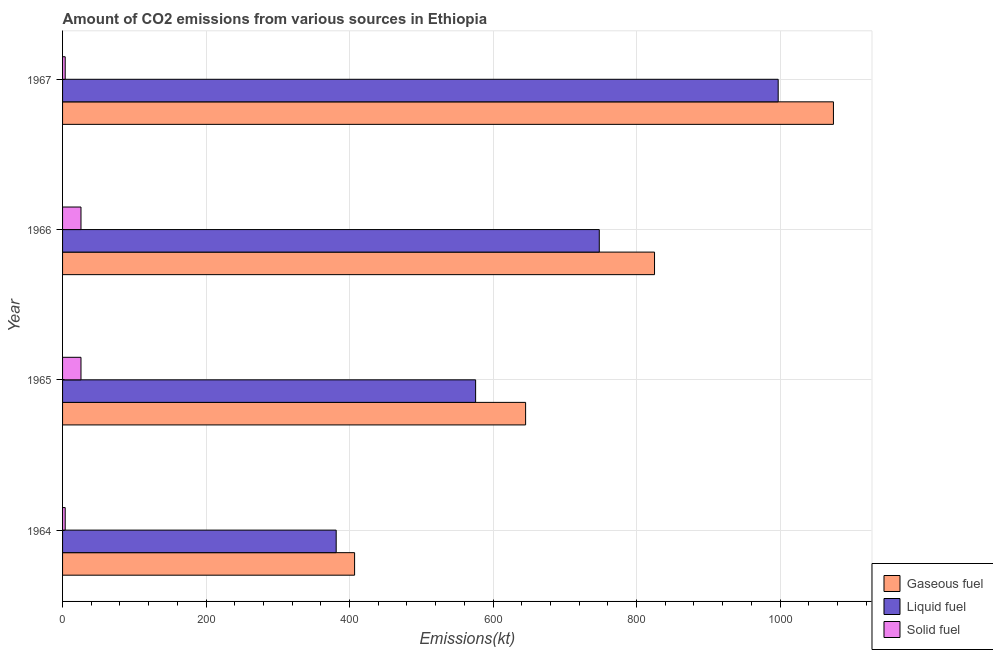How many bars are there on the 4th tick from the bottom?
Give a very brief answer. 3. What is the label of the 3rd group of bars from the top?
Your response must be concise. 1965. In how many cases, is the number of bars for a given year not equal to the number of legend labels?
Your response must be concise. 0. What is the amount of co2 emissions from solid fuel in 1964?
Provide a succinct answer. 3.67. Across all years, what is the maximum amount of co2 emissions from liquid fuel?
Offer a very short reply. 997.42. Across all years, what is the minimum amount of co2 emissions from liquid fuel?
Provide a succinct answer. 381.37. In which year was the amount of co2 emissions from gaseous fuel maximum?
Your response must be concise. 1967. In which year was the amount of co2 emissions from liquid fuel minimum?
Ensure brevity in your answer.  1964. What is the total amount of co2 emissions from gaseous fuel in the graph?
Offer a terse response. 2951.93. What is the difference between the amount of co2 emissions from solid fuel in 1964 and that in 1966?
Your response must be concise. -22. What is the difference between the amount of co2 emissions from liquid fuel in 1966 and the amount of co2 emissions from gaseous fuel in 1965?
Your response must be concise. 102.68. What is the average amount of co2 emissions from liquid fuel per year?
Provide a short and direct response. 675.64. In the year 1967, what is the difference between the amount of co2 emissions from liquid fuel and amount of co2 emissions from solid fuel?
Your answer should be very brief. 993.76. What is the ratio of the amount of co2 emissions from gaseous fuel in 1964 to that in 1967?
Offer a terse response. 0.38. Is the amount of co2 emissions from gaseous fuel in 1965 less than that in 1966?
Offer a terse response. Yes. Is the difference between the amount of co2 emissions from gaseous fuel in 1965 and 1967 greater than the difference between the amount of co2 emissions from solid fuel in 1965 and 1967?
Your answer should be compact. No. What is the difference between the highest and the second highest amount of co2 emissions from gaseous fuel?
Provide a short and direct response. 249.36. What is the difference between the highest and the lowest amount of co2 emissions from liquid fuel?
Offer a terse response. 616.06. In how many years, is the amount of co2 emissions from liquid fuel greater than the average amount of co2 emissions from liquid fuel taken over all years?
Provide a succinct answer. 2. Is the sum of the amount of co2 emissions from solid fuel in 1964 and 1967 greater than the maximum amount of co2 emissions from liquid fuel across all years?
Offer a terse response. No. What does the 1st bar from the top in 1967 represents?
Your answer should be very brief. Solid fuel. What does the 1st bar from the bottom in 1967 represents?
Make the answer very short. Gaseous fuel. How many bars are there?
Provide a succinct answer. 12. How many years are there in the graph?
Provide a short and direct response. 4. Are the values on the major ticks of X-axis written in scientific E-notation?
Provide a succinct answer. No. Does the graph contain any zero values?
Offer a very short reply. No. Where does the legend appear in the graph?
Make the answer very short. Bottom right. How are the legend labels stacked?
Your response must be concise. Vertical. What is the title of the graph?
Keep it short and to the point. Amount of CO2 emissions from various sources in Ethiopia. Does "Injury" appear as one of the legend labels in the graph?
Offer a terse response. No. What is the label or title of the X-axis?
Keep it short and to the point. Emissions(kt). What is the label or title of the Y-axis?
Make the answer very short. Year. What is the Emissions(kt) in Gaseous fuel in 1964?
Give a very brief answer. 407.04. What is the Emissions(kt) in Liquid fuel in 1964?
Offer a terse response. 381.37. What is the Emissions(kt) in Solid fuel in 1964?
Offer a very short reply. 3.67. What is the Emissions(kt) of Gaseous fuel in 1965?
Your response must be concise. 645.39. What is the Emissions(kt) of Liquid fuel in 1965?
Make the answer very short. 575.72. What is the Emissions(kt) in Solid fuel in 1965?
Your answer should be very brief. 25.67. What is the Emissions(kt) of Gaseous fuel in 1966?
Provide a succinct answer. 825.08. What is the Emissions(kt) in Liquid fuel in 1966?
Your answer should be very brief. 748.07. What is the Emissions(kt) in Solid fuel in 1966?
Keep it short and to the point. 25.67. What is the Emissions(kt) of Gaseous fuel in 1967?
Your answer should be very brief. 1074.43. What is the Emissions(kt) in Liquid fuel in 1967?
Provide a short and direct response. 997.42. What is the Emissions(kt) of Solid fuel in 1967?
Your response must be concise. 3.67. Across all years, what is the maximum Emissions(kt) of Gaseous fuel?
Offer a very short reply. 1074.43. Across all years, what is the maximum Emissions(kt) in Liquid fuel?
Your response must be concise. 997.42. Across all years, what is the maximum Emissions(kt) of Solid fuel?
Provide a succinct answer. 25.67. Across all years, what is the minimum Emissions(kt) in Gaseous fuel?
Give a very brief answer. 407.04. Across all years, what is the minimum Emissions(kt) of Liquid fuel?
Keep it short and to the point. 381.37. Across all years, what is the minimum Emissions(kt) of Solid fuel?
Keep it short and to the point. 3.67. What is the total Emissions(kt) of Gaseous fuel in the graph?
Ensure brevity in your answer.  2951.93. What is the total Emissions(kt) of Liquid fuel in the graph?
Give a very brief answer. 2702.58. What is the total Emissions(kt) of Solid fuel in the graph?
Your answer should be very brief. 58.67. What is the difference between the Emissions(kt) in Gaseous fuel in 1964 and that in 1965?
Give a very brief answer. -238.35. What is the difference between the Emissions(kt) of Liquid fuel in 1964 and that in 1965?
Keep it short and to the point. -194.35. What is the difference between the Emissions(kt) in Solid fuel in 1964 and that in 1965?
Keep it short and to the point. -22. What is the difference between the Emissions(kt) in Gaseous fuel in 1964 and that in 1966?
Your response must be concise. -418.04. What is the difference between the Emissions(kt) of Liquid fuel in 1964 and that in 1966?
Offer a terse response. -366.7. What is the difference between the Emissions(kt) of Solid fuel in 1964 and that in 1966?
Give a very brief answer. -22. What is the difference between the Emissions(kt) in Gaseous fuel in 1964 and that in 1967?
Offer a very short reply. -667.39. What is the difference between the Emissions(kt) in Liquid fuel in 1964 and that in 1967?
Provide a short and direct response. -616.06. What is the difference between the Emissions(kt) of Solid fuel in 1964 and that in 1967?
Offer a terse response. 0. What is the difference between the Emissions(kt) in Gaseous fuel in 1965 and that in 1966?
Ensure brevity in your answer.  -179.68. What is the difference between the Emissions(kt) of Liquid fuel in 1965 and that in 1966?
Offer a very short reply. -172.35. What is the difference between the Emissions(kt) of Solid fuel in 1965 and that in 1966?
Offer a very short reply. 0. What is the difference between the Emissions(kt) in Gaseous fuel in 1965 and that in 1967?
Give a very brief answer. -429.04. What is the difference between the Emissions(kt) of Liquid fuel in 1965 and that in 1967?
Your response must be concise. -421.7. What is the difference between the Emissions(kt) of Solid fuel in 1965 and that in 1967?
Offer a terse response. 22. What is the difference between the Emissions(kt) of Gaseous fuel in 1966 and that in 1967?
Give a very brief answer. -249.36. What is the difference between the Emissions(kt) of Liquid fuel in 1966 and that in 1967?
Ensure brevity in your answer.  -249.36. What is the difference between the Emissions(kt) in Solid fuel in 1966 and that in 1967?
Provide a succinct answer. 22. What is the difference between the Emissions(kt) of Gaseous fuel in 1964 and the Emissions(kt) of Liquid fuel in 1965?
Keep it short and to the point. -168.68. What is the difference between the Emissions(kt) in Gaseous fuel in 1964 and the Emissions(kt) in Solid fuel in 1965?
Provide a succinct answer. 381.37. What is the difference between the Emissions(kt) of Liquid fuel in 1964 and the Emissions(kt) of Solid fuel in 1965?
Your answer should be compact. 355.7. What is the difference between the Emissions(kt) in Gaseous fuel in 1964 and the Emissions(kt) in Liquid fuel in 1966?
Your answer should be compact. -341.03. What is the difference between the Emissions(kt) in Gaseous fuel in 1964 and the Emissions(kt) in Solid fuel in 1966?
Make the answer very short. 381.37. What is the difference between the Emissions(kt) of Liquid fuel in 1964 and the Emissions(kt) of Solid fuel in 1966?
Provide a short and direct response. 355.7. What is the difference between the Emissions(kt) of Gaseous fuel in 1964 and the Emissions(kt) of Liquid fuel in 1967?
Keep it short and to the point. -590.39. What is the difference between the Emissions(kt) of Gaseous fuel in 1964 and the Emissions(kt) of Solid fuel in 1967?
Keep it short and to the point. 403.37. What is the difference between the Emissions(kt) in Liquid fuel in 1964 and the Emissions(kt) in Solid fuel in 1967?
Provide a succinct answer. 377.7. What is the difference between the Emissions(kt) in Gaseous fuel in 1965 and the Emissions(kt) in Liquid fuel in 1966?
Offer a terse response. -102.68. What is the difference between the Emissions(kt) of Gaseous fuel in 1965 and the Emissions(kt) of Solid fuel in 1966?
Give a very brief answer. 619.72. What is the difference between the Emissions(kt) in Liquid fuel in 1965 and the Emissions(kt) in Solid fuel in 1966?
Offer a very short reply. 550.05. What is the difference between the Emissions(kt) in Gaseous fuel in 1965 and the Emissions(kt) in Liquid fuel in 1967?
Your answer should be very brief. -352.03. What is the difference between the Emissions(kt) of Gaseous fuel in 1965 and the Emissions(kt) of Solid fuel in 1967?
Your answer should be very brief. 641.73. What is the difference between the Emissions(kt) of Liquid fuel in 1965 and the Emissions(kt) of Solid fuel in 1967?
Your answer should be compact. 572.05. What is the difference between the Emissions(kt) of Gaseous fuel in 1966 and the Emissions(kt) of Liquid fuel in 1967?
Make the answer very short. -172.35. What is the difference between the Emissions(kt) in Gaseous fuel in 1966 and the Emissions(kt) in Solid fuel in 1967?
Provide a short and direct response. 821.41. What is the difference between the Emissions(kt) of Liquid fuel in 1966 and the Emissions(kt) of Solid fuel in 1967?
Ensure brevity in your answer.  744.4. What is the average Emissions(kt) of Gaseous fuel per year?
Ensure brevity in your answer.  737.98. What is the average Emissions(kt) in Liquid fuel per year?
Your answer should be very brief. 675.64. What is the average Emissions(kt) in Solid fuel per year?
Ensure brevity in your answer.  14.67. In the year 1964, what is the difference between the Emissions(kt) of Gaseous fuel and Emissions(kt) of Liquid fuel?
Give a very brief answer. 25.67. In the year 1964, what is the difference between the Emissions(kt) of Gaseous fuel and Emissions(kt) of Solid fuel?
Provide a succinct answer. 403.37. In the year 1964, what is the difference between the Emissions(kt) of Liquid fuel and Emissions(kt) of Solid fuel?
Make the answer very short. 377.7. In the year 1965, what is the difference between the Emissions(kt) of Gaseous fuel and Emissions(kt) of Liquid fuel?
Keep it short and to the point. 69.67. In the year 1965, what is the difference between the Emissions(kt) of Gaseous fuel and Emissions(kt) of Solid fuel?
Ensure brevity in your answer.  619.72. In the year 1965, what is the difference between the Emissions(kt) of Liquid fuel and Emissions(kt) of Solid fuel?
Provide a short and direct response. 550.05. In the year 1966, what is the difference between the Emissions(kt) of Gaseous fuel and Emissions(kt) of Liquid fuel?
Ensure brevity in your answer.  77.01. In the year 1966, what is the difference between the Emissions(kt) of Gaseous fuel and Emissions(kt) of Solid fuel?
Your answer should be compact. 799.41. In the year 1966, what is the difference between the Emissions(kt) of Liquid fuel and Emissions(kt) of Solid fuel?
Make the answer very short. 722.4. In the year 1967, what is the difference between the Emissions(kt) in Gaseous fuel and Emissions(kt) in Liquid fuel?
Give a very brief answer. 77.01. In the year 1967, what is the difference between the Emissions(kt) in Gaseous fuel and Emissions(kt) in Solid fuel?
Make the answer very short. 1070.76. In the year 1967, what is the difference between the Emissions(kt) of Liquid fuel and Emissions(kt) of Solid fuel?
Offer a very short reply. 993.76. What is the ratio of the Emissions(kt) in Gaseous fuel in 1964 to that in 1965?
Your answer should be very brief. 0.63. What is the ratio of the Emissions(kt) in Liquid fuel in 1964 to that in 1965?
Ensure brevity in your answer.  0.66. What is the ratio of the Emissions(kt) of Solid fuel in 1964 to that in 1965?
Your answer should be compact. 0.14. What is the ratio of the Emissions(kt) in Gaseous fuel in 1964 to that in 1966?
Make the answer very short. 0.49. What is the ratio of the Emissions(kt) in Liquid fuel in 1964 to that in 1966?
Offer a terse response. 0.51. What is the ratio of the Emissions(kt) in Solid fuel in 1964 to that in 1966?
Provide a short and direct response. 0.14. What is the ratio of the Emissions(kt) in Gaseous fuel in 1964 to that in 1967?
Make the answer very short. 0.38. What is the ratio of the Emissions(kt) of Liquid fuel in 1964 to that in 1967?
Offer a terse response. 0.38. What is the ratio of the Emissions(kt) of Gaseous fuel in 1965 to that in 1966?
Keep it short and to the point. 0.78. What is the ratio of the Emissions(kt) of Liquid fuel in 1965 to that in 1966?
Keep it short and to the point. 0.77. What is the ratio of the Emissions(kt) of Gaseous fuel in 1965 to that in 1967?
Keep it short and to the point. 0.6. What is the ratio of the Emissions(kt) in Liquid fuel in 1965 to that in 1967?
Keep it short and to the point. 0.58. What is the ratio of the Emissions(kt) in Gaseous fuel in 1966 to that in 1967?
Ensure brevity in your answer.  0.77. What is the difference between the highest and the second highest Emissions(kt) of Gaseous fuel?
Give a very brief answer. 249.36. What is the difference between the highest and the second highest Emissions(kt) in Liquid fuel?
Provide a short and direct response. 249.36. What is the difference between the highest and the second highest Emissions(kt) in Solid fuel?
Your response must be concise. 0. What is the difference between the highest and the lowest Emissions(kt) in Gaseous fuel?
Give a very brief answer. 667.39. What is the difference between the highest and the lowest Emissions(kt) of Liquid fuel?
Ensure brevity in your answer.  616.06. What is the difference between the highest and the lowest Emissions(kt) in Solid fuel?
Provide a succinct answer. 22. 